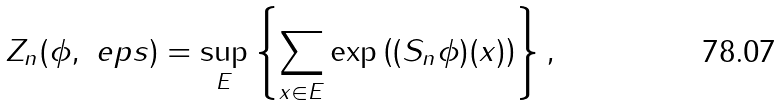Convert formula to latex. <formula><loc_0><loc_0><loc_500><loc_500>Z _ { n } ( \phi , \ e p s ) = \sup _ { E } \left \{ \sum _ { x \in E } \exp \left ( ( S _ { n } \phi ) ( x ) \right ) \right \} ,</formula> 